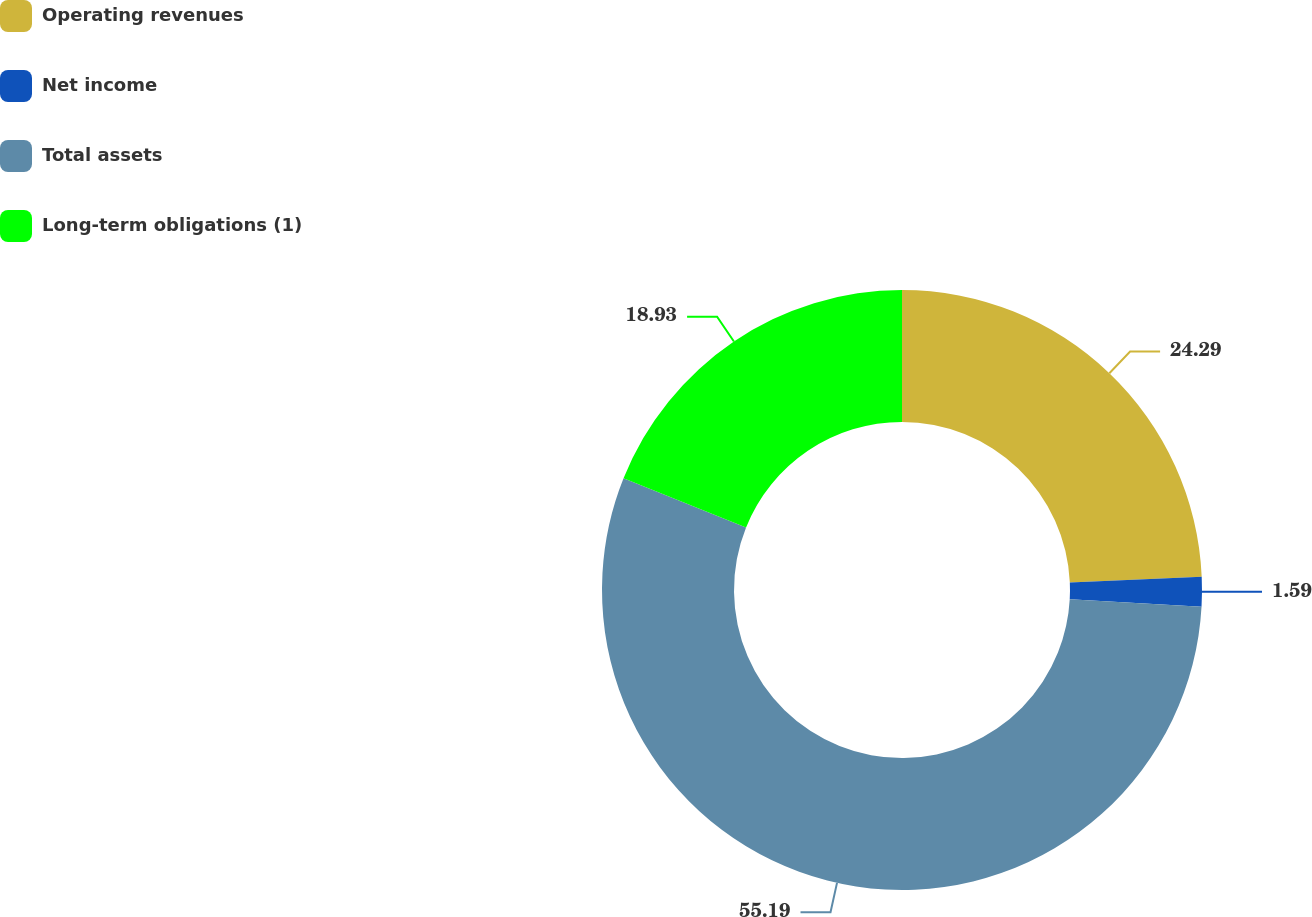Convert chart. <chart><loc_0><loc_0><loc_500><loc_500><pie_chart><fcel>Operating revenues<fcel>Net income<fcel>Total assets<fcel>Long-term obligations (1)<nl><fcel>24.29%<fcel>1.59%<fcel>55.18%<fcel>18.93%<nl></chart> 